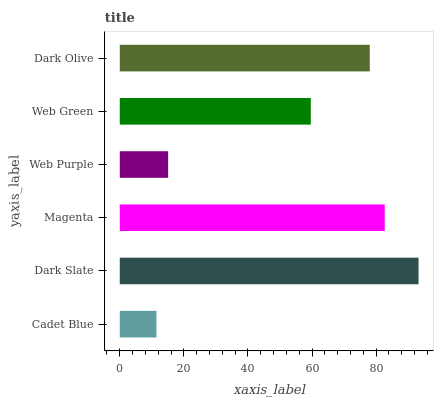Is Cadet Blue the minimum?
Answer yes or no. Yes. Is Dark Slate the maximum?
Answer yes or no. Yes. Is Magenta the minimum?
Answer yes or no. No. Is Magenta the maximum?
Answer yes or no. No. Is Dark Slate greater than Magenta?
Answer yes or no. Yes. Is Magenta less than Dark Slate?
Answer yes or no. Yes. Is Magenta greater than Dark Slate?
Answer yes or no. No. Is Dark Slate less than Magenta?
Answer yes or no. No. Is Dark Olive the high median?
Answer yes or no. Yes. Is Web Green the low median?
Answer yes or no. Yes. Is Dark Slate the high median?
Answer yes or no. No. Is Dark Slate the low median?
Answer yes or no. No. 